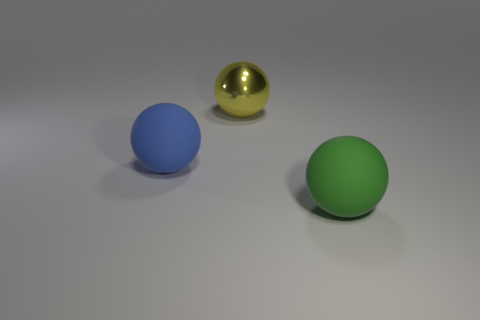Subtract all green rubber spheres. How many spheres are left? 2 Add 1 large rubber spheres. How many objects exist? 4 Subtract all cyan balls. Subtract all yellow cylinders. How many balls are left? 3 Subtract all large rubber balls. Subtract all green balls. How many objects are left? 0 Add 2 yellow metallic objects. How many yellow metallic objects are left? 3 Add 3 tiny cyan matte things. How many tiny cyan matte things exist? 3 Subtract 0 red balls. How many objects are left? 3 